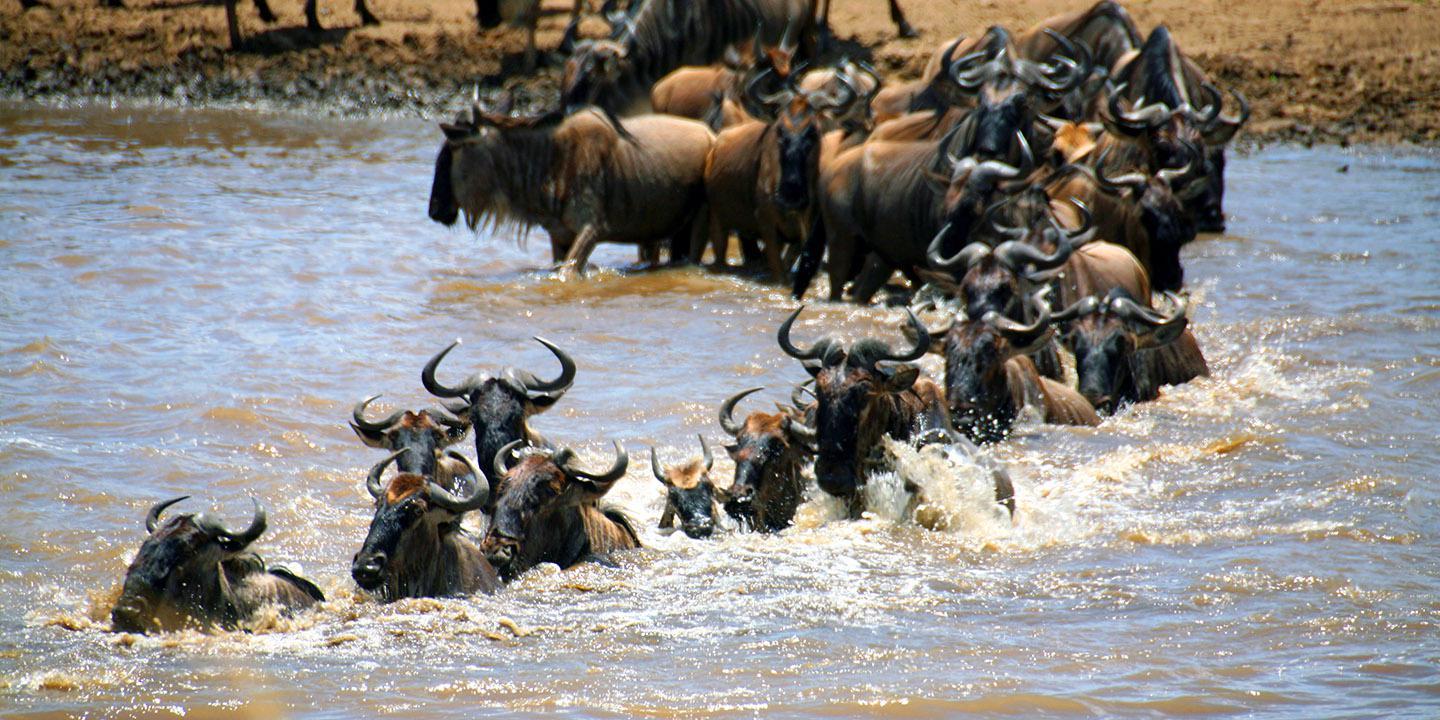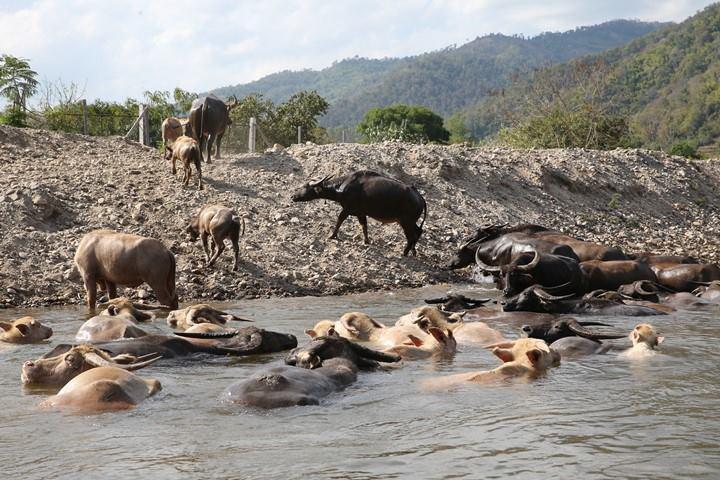The first image is the image on the left, the second image is the image on the right. Analyze the images presented: Is the assertion "Each image shows multiple horned animals standing at least chest-deep in water, and one image includes some animals standing behind water on higher ground near a fence." valid? Answer yes or no. Yes. The first image is the image on the left, the second image is the image on the right. Examine the images to the left and right. Is the description "None of the animals are completely in the water." accurate? Answer yes or no. No. 